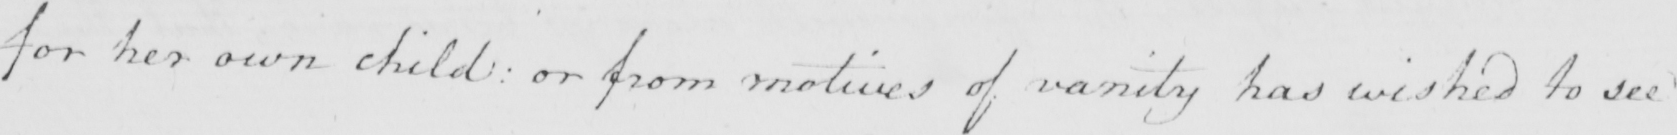Please provide the text content of this handwritten line. for her own child :  or from motives of vanity has wished to see 